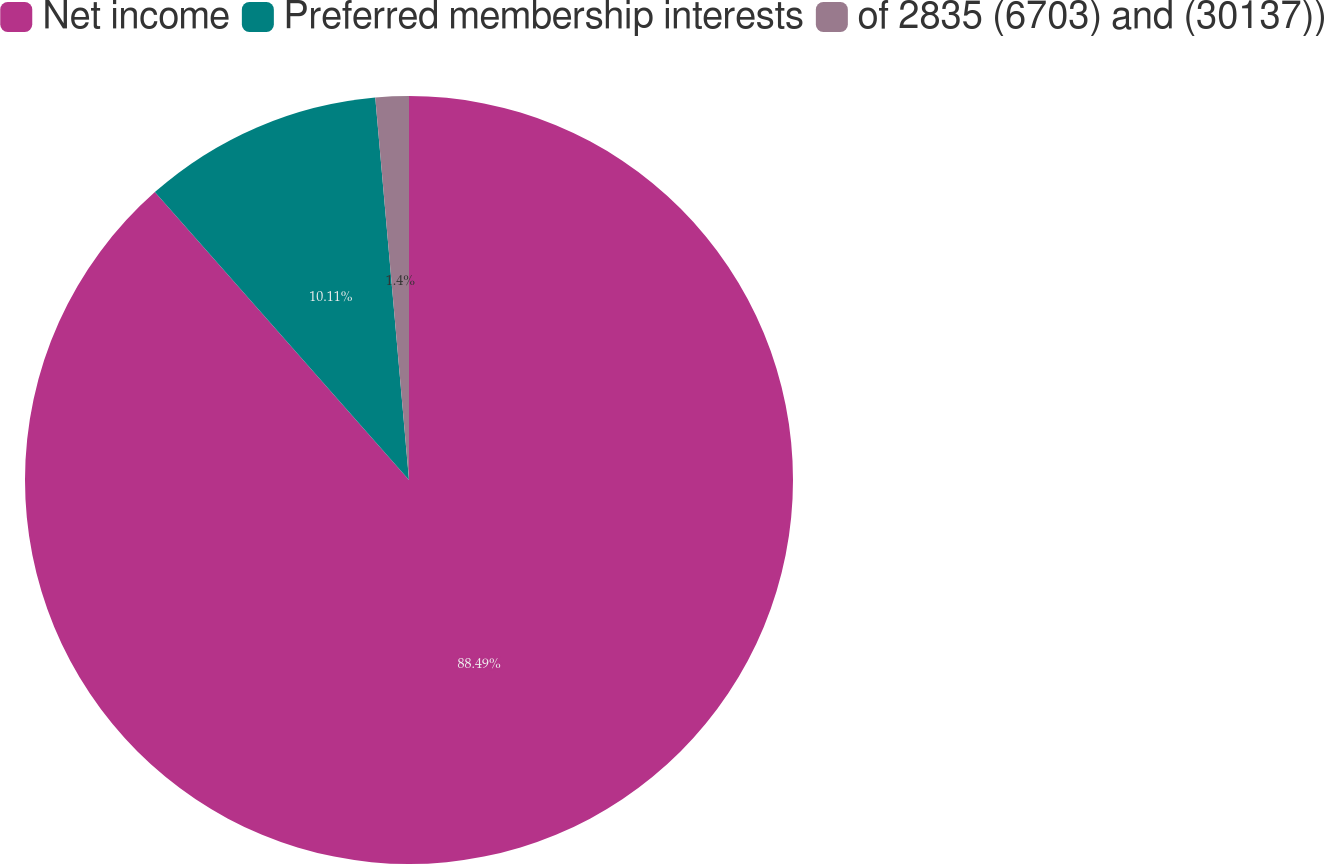Convert chart. <chart><loc_0><loc_0><loc_500><loc_500><pie_chart><fcel>Net income<fcel>Preferred membership interests<fcel>of 2835 (6703) and (30137))<nl><fcel>88.49%<fcel>10.11%<fcel>1.4%<nl></chart> 